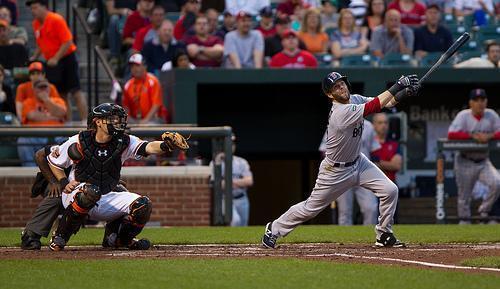How many people are bating?
Give a very brief answer. 1. 